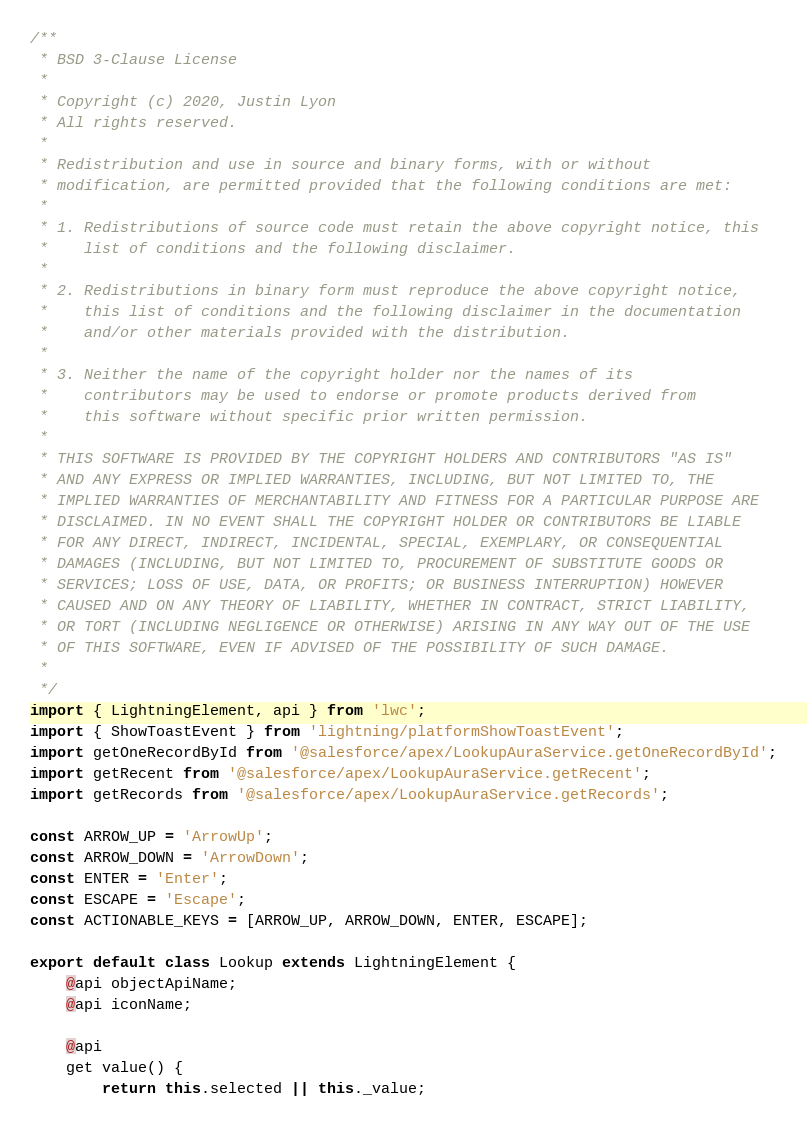Convert code to text. <code><loc_0><loc_0><loc_500><loc_500><_JavaScript_>/**
 * BSD 3-Clause License
 *
 * Copyright (c) 2020, Justin Lyon
 * All rights reserved.
 *
 * Redistribution and use in source and binary forms, with or without
 * modification, are permitted provided that the following conditions are met:
 *
 * 1. Redistributions of source code must retain the above copyright notice, this
 *    list of conditions and the following disclaimer.
 *
 * 2. Redistributions in binary form must reproduce the above copyright notice,
 *    this list of conditions and the following disclaimer in the documentation
 *    and/or other materials provided with the distribution.
 *
 * 3. Neither the name of the copyright holder nor the names of its
 *    contributors may be used to endorse or promote products derived from
 *    this software without specific prior written permission.
 *
 * THIS SOFTWARE IS PROVIDED BY THE COPYRIGHT HOLDERS AND CONTRIBUTORS "AS IS"
 * AND ANY EXPRESS OR IMPLIED WARRANTIES, INCLUDING, BUT NOT LIMITED TO, THE
 * IMPLIED WARRANTIES OF MERCHANTABILITY AND FITNESS FOR A PARTICULAR PURPOSE ARE
 * DISCLAIMED. IN NO EVENT SHALL THE COPYRIGHT HOLDER OR CONTRIBUTORS BE LIABLE
 * FOR ANY DIRECT, INDIRECT, INCIDENTAL, SPECIAL, EXEMPLARY, OR CONSEQUENTIAL
 * DAMAGES (INCLUDING, BUT NOT LIMITED TO, PROCUREMENT OF SUBSTITUTE GOODS OR
 * SERVICES; LOSS OF USE, DATA, OR PROFITS; OR BUSINESS INTERRUPTION) HOWEVER
 * CAUSED AND ON ANY THEORY OF LIABILITY, WHETHER IN CONTRACT, STRICT LIABILITY,
 * OR TORT (INCLUDING NEGLIGENCE OR OTHERWISE) ARISING IN ANY WAY OUT OF THE USE
 * OF THIS SOFTWARE, EVEN IF ADVISED OF THE POSSIBILITY OF SUCH DAMAGE.
 *
 */
import { LightningElement, api } from 'lwc';
import { ShowToastEvent } from 'lightning/platformShowToastEvent';
import getOneRecordById from '@salesforce/apex/LookupAuraService.getOneRecordById';
import getRecent from '@salesforce/apex/LookupAuraService.getRecent';
import getRecords from '@salesforce/apex/LookupAuraService.getRecords';

const ARROW_UP = 'ArrowUp';
const ARROW_DOWN = 'ArrowDown';
const ENTER = 'Enter';
const ESCAPE = 'Escape';
const ACTIONABLE_KEYS = [ARROW_UP, ARROW_DOWN, ENTER, ESCAPE];

export default class Lookup extends LightningElement {
    @api objectApiName;
    @api iconName;

    @api
    get value() {
        return this.selected || this._value;</code> 